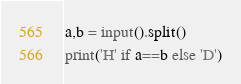<code> <loc_0><loc_0><loc_500><loc_500><_Python_>a,b = input().split()
print('H' if a==b else 'D')</code> 